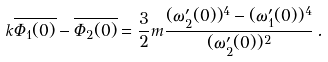Convert formula to latex. <formula><loc_0><loc_0><loc_500><loc_500>k \overline { \Phi _ { 1 } ( 0 ) } - \overline { \Phi _ { 2 } ( 0 ) } = \frac { 3 } { 2 } m \frac { ( \omega ^ { \prime } _ { 2 } ( 0 ) ) ^ { 4 } - ( \omega ^ { \prime } _ { 1 } ( 0 ) ) ^ { 4 } } { ( \omega ^ { \prime } _ { 2 } ( 0 ) ) ^ { 2 } } \, .</formula> 